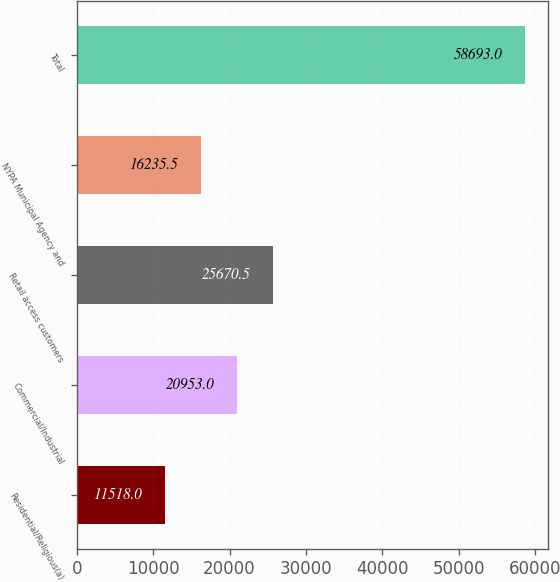Convert chart to OTSL. <chart><loc_0><loc_0><loc_500><loc_500><bar_chart><fcel>Residential/Religious(a)<fcel>Commercial/Industrial<fcel>Retail access customers<fcel>NYPA Municipal Agency and<fcel>Total<nl><fcel>11518<fcel>20953<fcel>25670.5<fcel>16235.5<fcel>58693<nl></chart> 